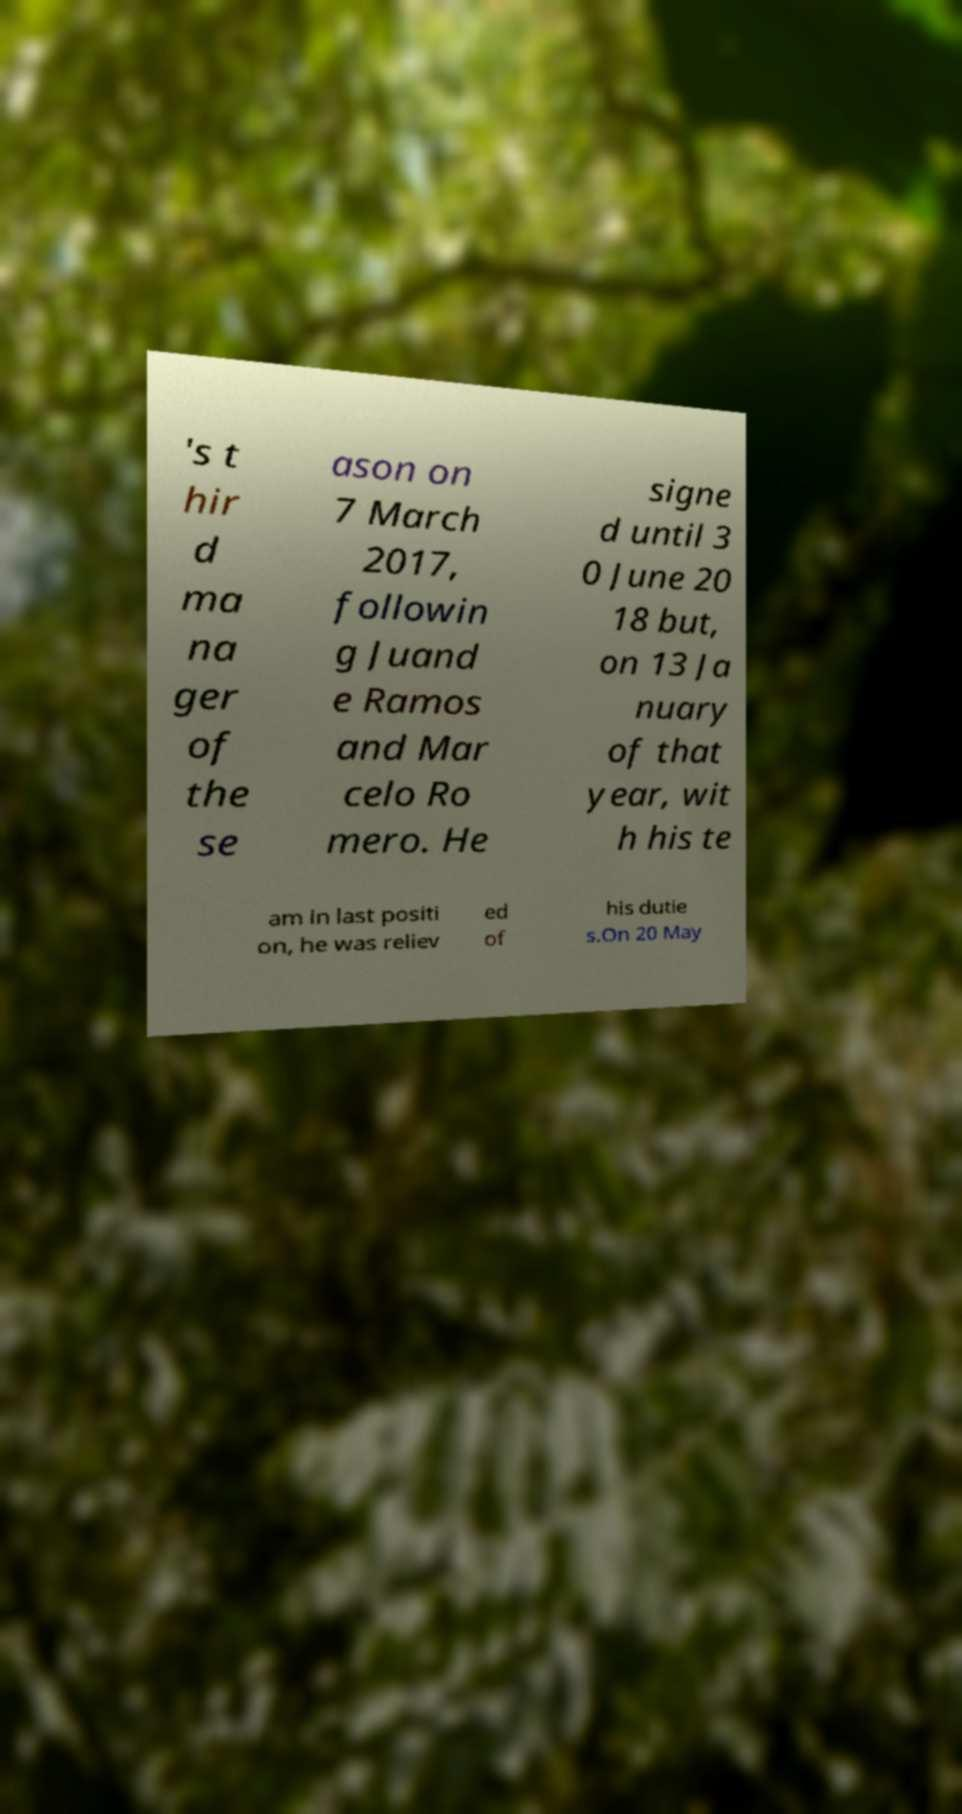For documentation purposes, I need the text within this image transcribed. Could you provide that? 's t hir d ma na ger of the se ason on 7 March 2017, followin g Juand e Ramos and Mar celo Ro mero. He signe d until 3 0 June 20 18 but, on 13 Ja nuary of that year, wit h his te am in last positi on, he was reliev ed of his dutie s.On 20 May 